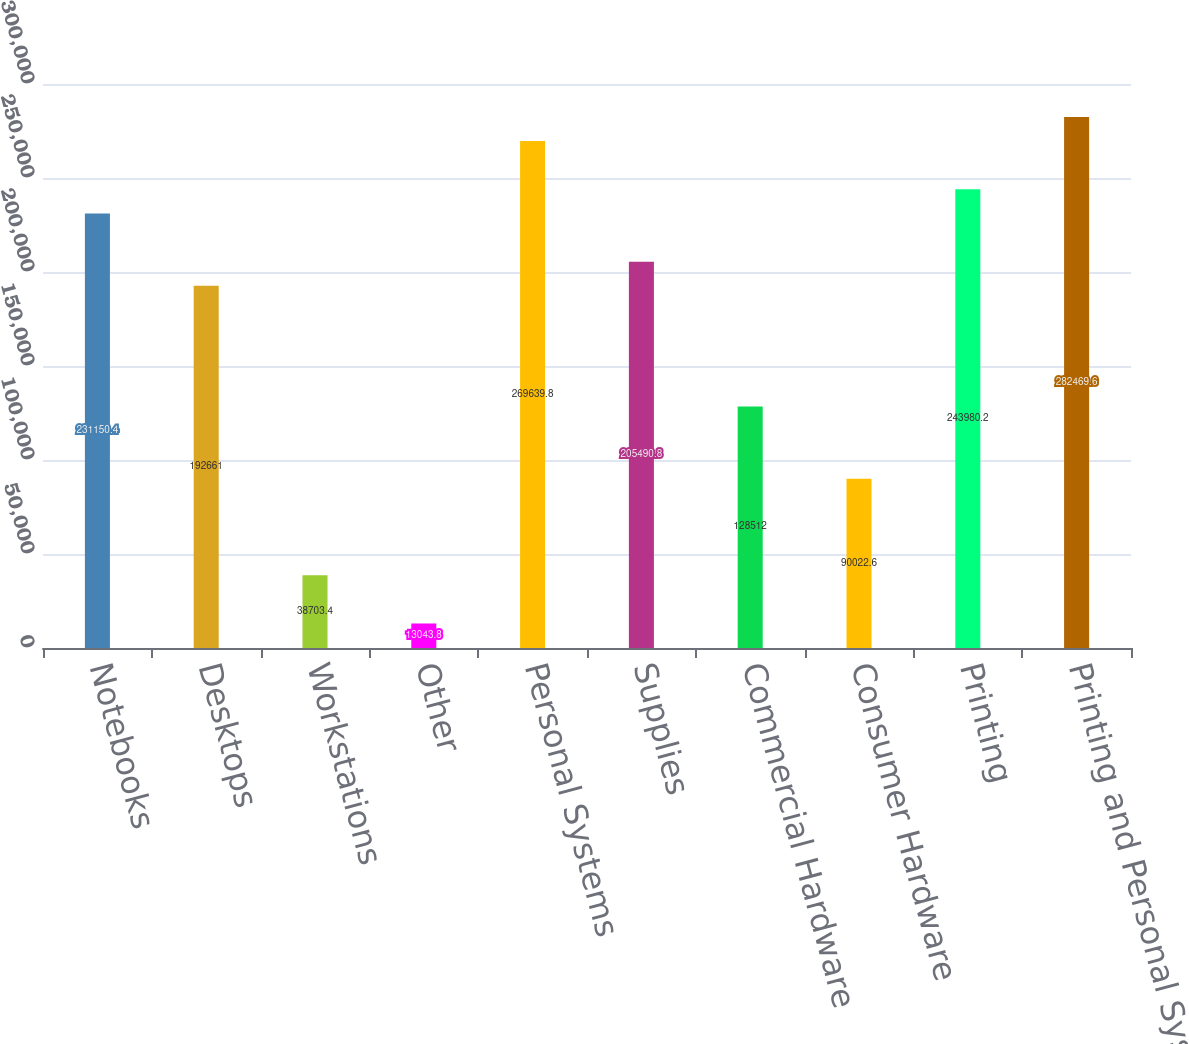Convert chart. <chart><loc_0><loc_0><loc_500><loc_500><bar_chart><fcel>Notebooks<fcel>Desktops<fcel>Workstations<fcel>Other<fcel>Personal Systems<fcel>Supplies<fcel>Commercial Hardware<fcel>Consumer Hardware<fcel>Printing<fcel>Printing and Personal Systems<nl><fcel>231150<fcel>192661<fcel>38703.4<fcel>13043.8<fcel>269640<fcel>205491<fcel>128512<fcel>90022.6<fcel>243980<fcel>282470<nl></chart> 